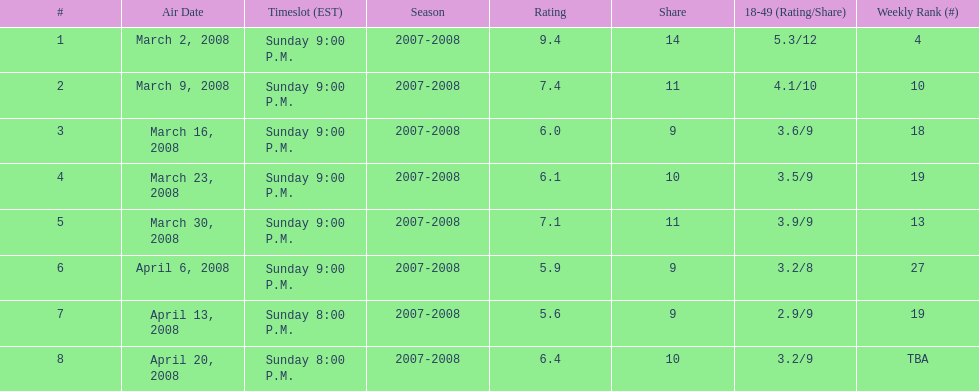The air date with the most viewers March 2, 2008. 